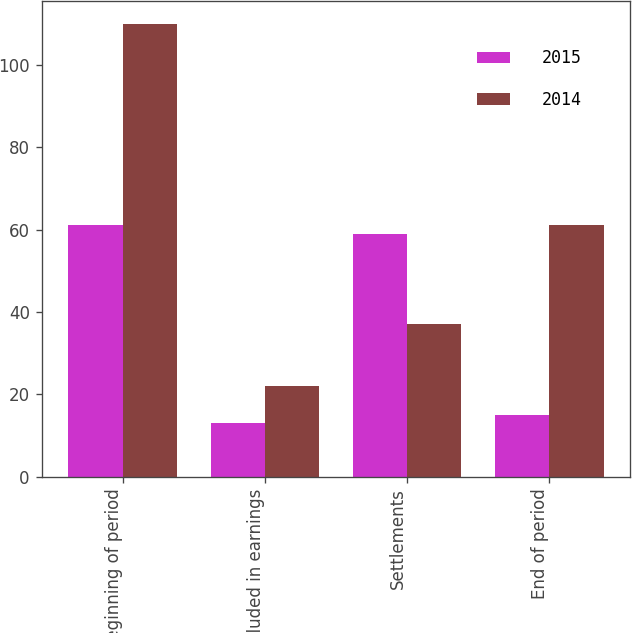<chart> <loc_0><loc_0><loc_500><loc_500><stacked_bar_chart><ecel><fcel>Beginning of period<fcel>Included in earnings<fcel>Settlements<fcel>End of period<nl><fcel>2015<fcel>61<fcel>13<fcel>59<fcel>15<nl><fcel>2014<fcel>110<fcel>22<fcel>37<fcel>61<nl></chart> 